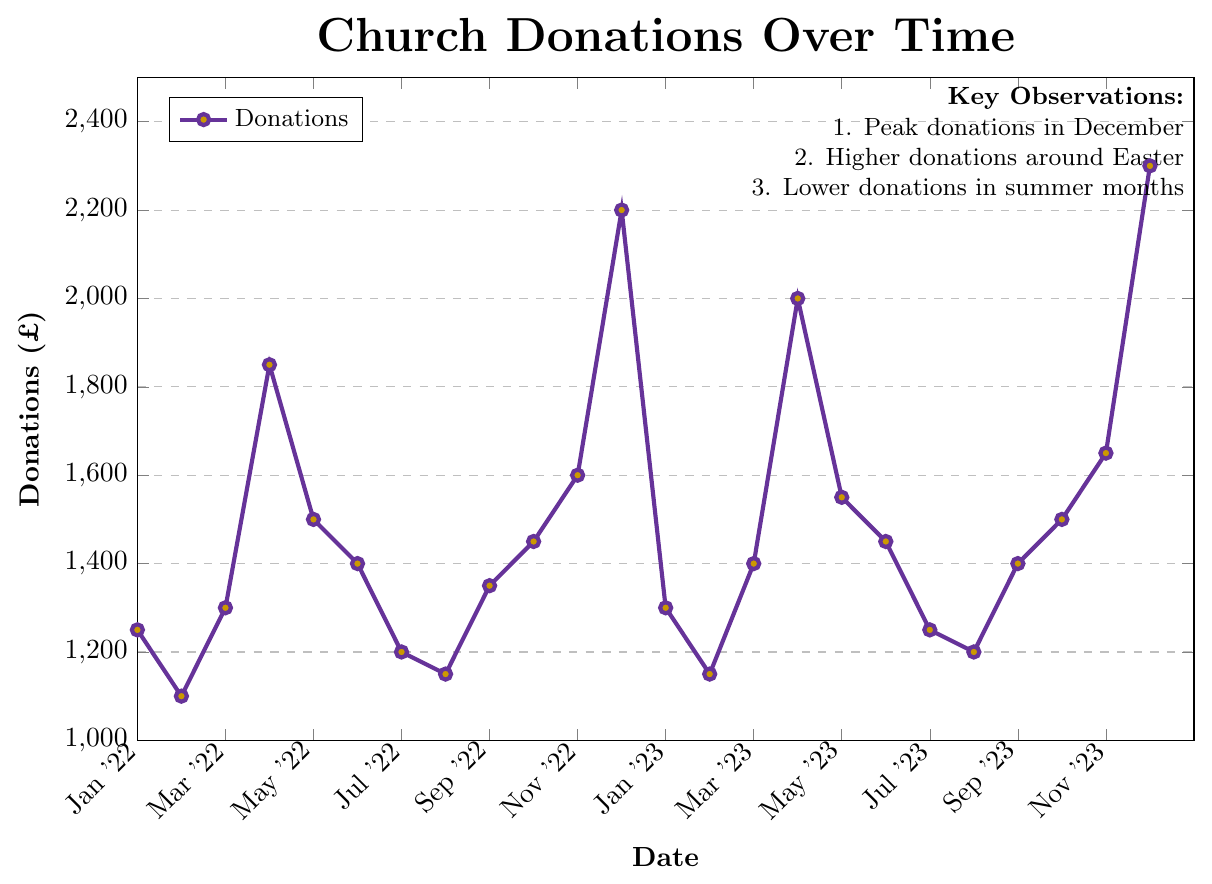What is the peak donation month in 2022? From the figure, observe the highest point for the year 2022. December has the highest donation at £2200.
Answer: December What is the difference in donations between December 2022 and December 2023? Locate the points for December 2022 and December 2023, observe their values (2200 and 2300 respectively). Calculate the difference: £2300 - £2200 = £100.
Answer: £100 Which two months had the lowest donations in 2022 and 2023 respectively? For 2022, February shows the lowest donation at £1100. For 2023, February also shows the lowest donation at £1150.
Answer: February 2022 and February 2023 By how much do donations increase from March to April in both 2022 and 2023? Locate the points for March and April of each year, then calculate the difference. For 2022, April(£1850) - March(£1300) = £550. For 2023, April(£2000) - March(£1400) = £600.
Answer: £550 in 2022 and £600 in 2023 In which months do donations experience a seasonal low in summer? Identify the lowest points in the summer months (June, July, August). Lowest donations are in July 2022 (£1200) and July 2023 (£1250).
Answer: July What is the average donation amount over the two Decembers? Add the donation amounts for December 2022 (£2200) and December 2023 (£2300), then divide by 2. (2200 + 2300)/2 = £2250.
Answer: £2250 How do donations in Easter months (April) compare in 2022 and 2023? Locate the points for April 2022 (£1850) and April 2023 (£2000). Compare the values, noting that April 2023 is higher.
Answer: April 2023 is higher What is the trend in donations from June to December 2022? Observe the points from June (£1400) to December (£2200) 2022. The trend shows an increase in donations over these months.
Answer: Increasing What color represents the data points in the figure? Visually identify the colors of the points on the line in the plot. The points are purple with a gold filling.
Answer: Purple with gold filling 